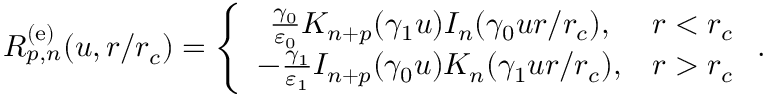<formula> <loc_0><loc_0><loc_500><loc_500>R _ { p , n } ^ { ( e ) } ( u , r / r _ { c } ) = \left \{ \begin{array} { c c } { \frac { \gamma _ { 0 } } { \varepsilon _ { 0 } } K _ { n + p } ( \gamma _ { 1 } u ) I _ { n } ( \gamma _ { 0 } u r / r _ { c } ) , } & { r < r _ { c } } \\ { - \frac { \gamma _ { 1 } } { \varepsilon _ { 1 } } I _ { n + p } ( \gamma _ { 0 } u ) K _ { n } ( \gamma _ { 1 } u r / r _ { c } ) , } & { r > r _ { c } } \end{array} .</formula> 